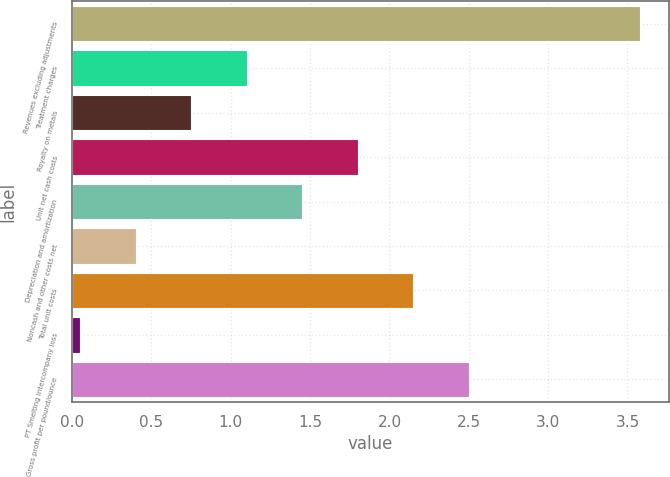<chart> <loc_0><loc_0><loc_500><loc_500><bar_chart><fcel>Revenues excluding adjustments<fcel>Treatment charges<fcel>Royalty on metals<fcel>Unit net cash costs<fcel>Depreciation and amortization<fcel>Noncash and other costs net<fcel>Total unit costs<fcel>PT Smelting intercompany loss<fcel>Gross profit per pound/ounce<nl><fcel>3.58<fcel>1.1<fcel>0.75<fcel>1.8<fcel>1.45<fcel>0.4<fcel>2.15<fcel>0.05<fcel>2.5<nl></chart> 